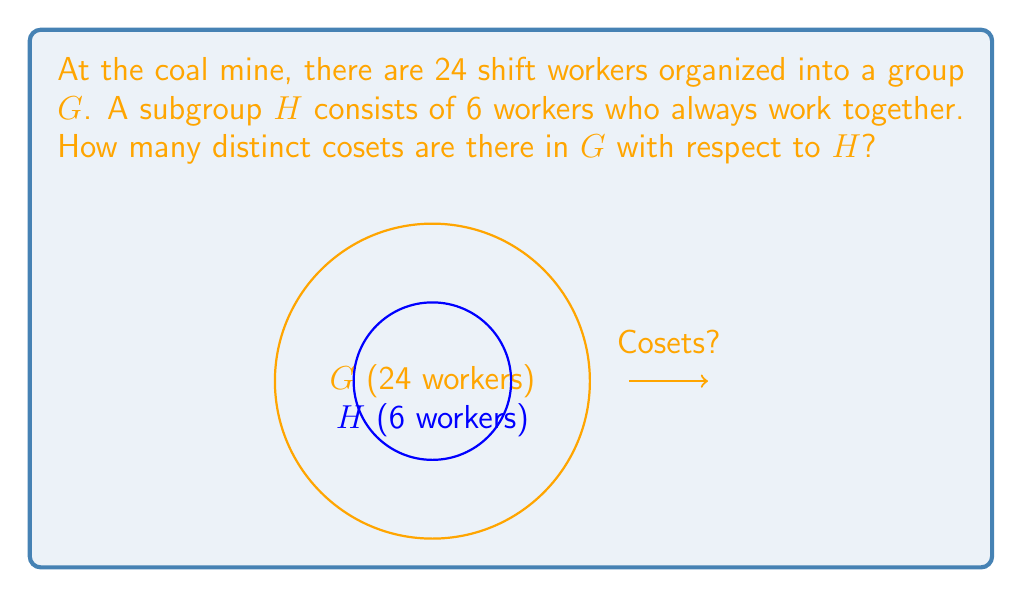Solve this math problem. Let's approach this step-by-step:

1) First, recall the Lagrange's Theorem, which states that for a finite group $G$ and a subgroup $H$ of $G$:

   $$|G| = |H| \cdot [G:H]$$

   Where $|G|$ is the order of $G$, $|H|$ is the order of $H$, and $[G:H]$ is the index of $H$ in $G$ (which is equal to the number of cosets).

2) In this case:
   $|G| = 24$ (total number of shift workers)
   $|H| = 6$ (number of workers in the subgroup)

3) Let's substitute these values into Lagrange's Theorem:

   $$24 = 6 \cdot [G:H]$$

4) Now, we can solve for $[G:H]$:

   $$[G:H] = \frac{24}{6} = 4$$

5) Therefore, the number of distinct cosets of $H$ in $G$ is 4.

This means the 24 workers can be divided into 4 distinct groups of 6 workers each, where each group is a coset of $H$.
Answer: 4 